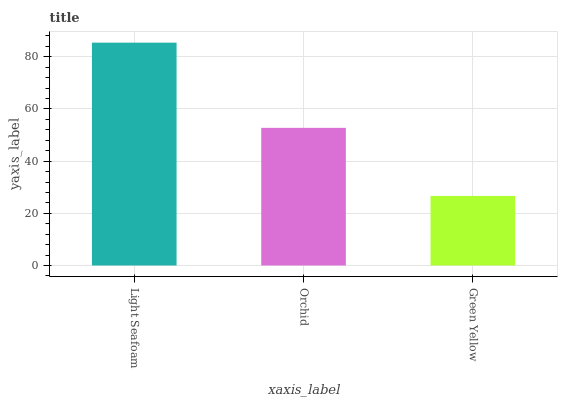Is Orchid the minimum?
Answer yes or no. No. Is Orchid the maximum?
Answer yes or no. No. Is Light Seafoam greater than Orchid?
Answer yes or no. Yes. Is Orchid less than Light Seafoam?
Answer yes or no. Yes. Is Orchid greater than Light Seafoam?
Answer yes or no. No. Is Light Seafoam less than Orchid?
Answer yes or no. No. Is Orchid the high median?
Answer yes or no. Yes. Is Orchid the low median?
Answer yes or no. Yes. Is Light Seafoam the high median?
Answer yes or no. No. Is Light Seafoam the low median?
Answer yes or no. No. 